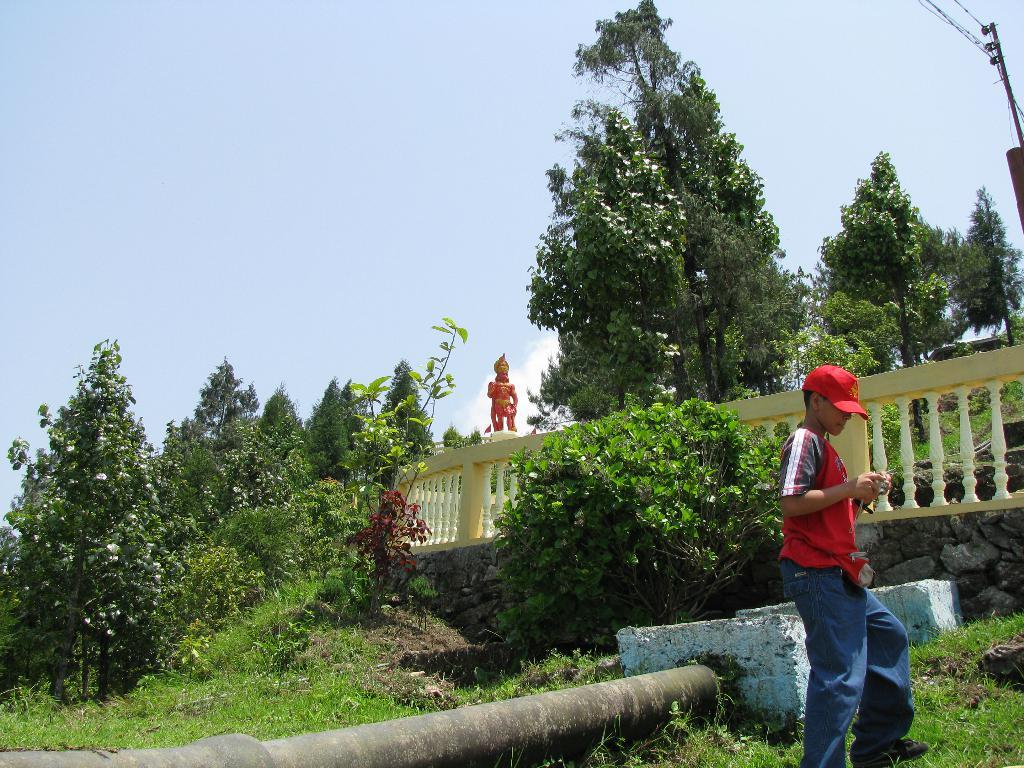Who is present in the image? There is a boy in the image. What is the boy wearing on his head? The boy is wearing a helmet. Where is the boy standing? The boy is standing on the ground. What type of vegetation can be seen in the image? There are trees in the image. What man-made object can be seen in the image? There is a pipe in the image. What structure is present in the image? There is a fence in the image. What type of artwork is visible in the image? There is a statue in the image. What is visible in the background of the image? The sky is visible in the background of the image. How much dust can be seen on the boy's helmet in the image? There is no dust visible on the boy's helmet in the image. --- Facts: 1. There is a car in the image. 2. The car is red. 3. The car has four wheels. 4. The car has a license plate. 5. The car is parked on the street. 6. There are people walking on the sidewalk. 7. There are streetlights present in the image. 8. The image is taken at night. Absurd Topics: ocean Conversation: What type of vehicle is present in the image? There is a car in the image. What is the color of the car? The car is red. How many wheels does the car have? The car has four wheels. What is attached to the back of the car? The car has a license plate. Where is the car located in the image? The car is parked on the street. What are the people doing in the image? There are people walking on the sidewalk. What type of lighting is present in the image? There are streetlights present in the image. What is the time of day depicted in the image? The image is taken at night. Reasoning: Let's think step by step in order to produce the conversation. We start by identifying the main subject of the image, which is the car. Next, we describe the specific features of the car, such as its color, the number of wheels it has, and the presence of a license plate. Then, we observe the actions of the people in the image, noting that they are walking on the sidewalk. After that, we describe the presence of streetlights in the image. Finally, we describe the time of day depicted in the image, which is night. Absurd Question/Answer: 